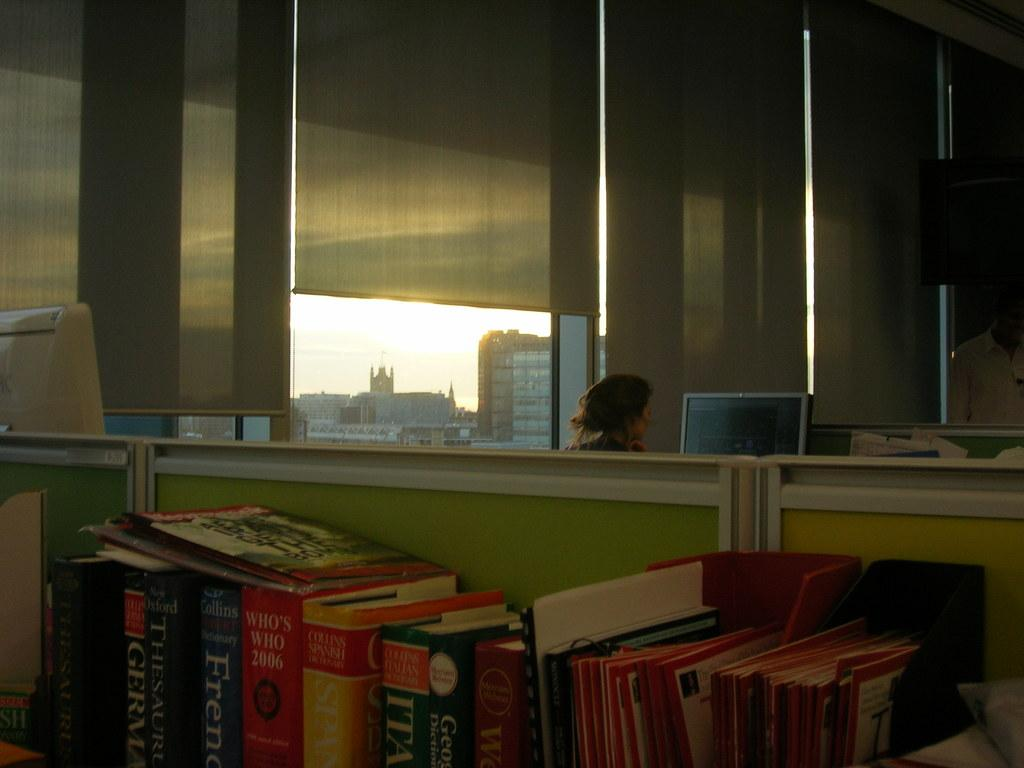<image>
Create a compact narrative representing the image presented. a mirrored wall over a bunch of books and one is a thesaurus 